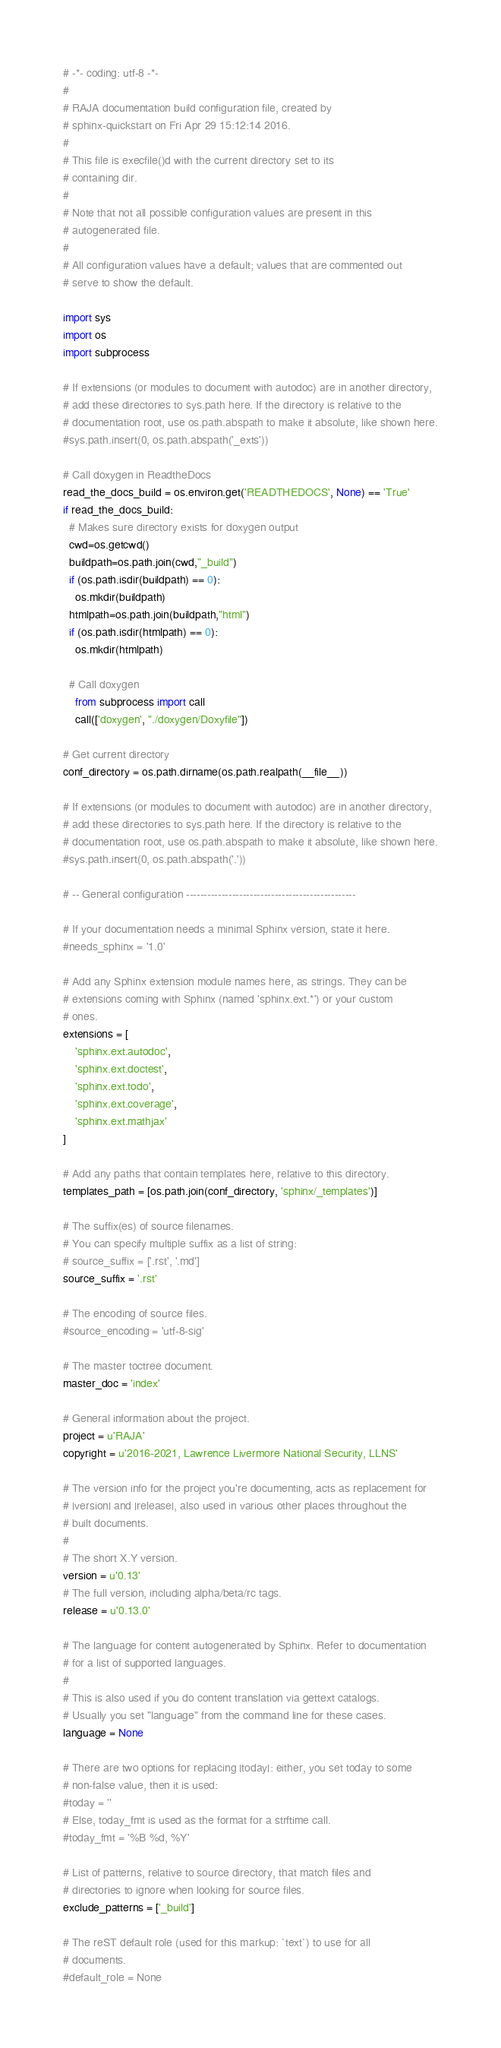<code> <loc_0><loc_0><loc_500><loc_500><_Python_># -*- coding: utf-8 -*-
#
# RAJA documentation build configuration file, created by
# sphinx-quickstart on Fri Apr 29 15:12:14 2016.
#
# This file is execfile()d with the current directory set to its
# containing dir.
#
# Note that not all possible configuration values are present in this
# autogenerated file.
#
# All configuration values have a default; values that are commented out
# serve to show the default.

import sys
import os
import subprocess

# If extensions (or modules to document with autodoc) are in another directory,
# add these directories to sys.path here. If the directory is relative to the
# documentation root, use os.path.abspath to make it absolute, like shown here.
#sys.path.insert(0, os.path.abspath('_exts'))

# Call doxygen in ReadtheDocs
read_the_docs_build = os.environ.get('READTHEDOCS', None) == 'True'
if read_the_docs_build:
  # Makes sure directory exists for doxygen output
  cwd=os.getcwd()
  buildpath=os.path.join(cwd,"_build")
  if (os.path.isdir(buildpath) == 0):
    os.mkdir(buildpath)
  htmlpath=os.path.join(buildpath,"html")
  if (os.path.isdir(htmlpath) == 0):
    os.mkdir(htmlpath)

  # Call doxygen
    from subprocess import call
    call(['doxygen', "./doxygen/Doxyfile"])

# Get current directory
conf_directory = os.path.dirname(os.path.realpath(__file__))

# If extensions (or modules to document with autodoc) are in another directory,
# add these directories to sys.path here. If the directory is relative to the
# documentation root, use os.path.abspath to make it absolute, like shown here.
#sys.path.insert(0, os.path.abspath('.'))

# -- General configuration ------------------------------------------------

# If your documentation needs a minimal Sphinx version, state it here.
#needs_sphinx = '1.0'

# Add any Sphinx extension module names here, as strings. They can be
# extensions coming with Sphinx (named 'sphinx.ext.*') or your custom
# ones.
extensions = [
    'sphinx.ext.autodoc',
    'sphinx.ext.doctest',
    'sphinx.ext.todo',
    'sphinx.ext.coverage',
    'sphinx.ext.mathjax'
]

# Add any paths that contain templates here, relative to this directory.
templates_path = [os.path.join(conf_directory, 'sphinx/_templates')]

# The suffix(es) of source filenames.
# You can specify multiple suffix as a list of string:
# source_suffix = ['.rst', '.md']
source_suffix = '.rst'

# The encoding of source files.
#source_encoding = 'utf-8-sig'

# The master toctree document.
master_doc = 'index'

# General information about the project.
project = u'RAJA'
copyright = u'2016-2021, Lawrence Livermore National Security, LLNS'

# The version info for the project you're documenting, acts as replacement for
# |version| and |release|, also used in various other places throughout the
# built documents.
#
# The short X.Y version.
version = u'0.13'
# The full version, including alpha/beta/rc tags.
release = u'0.13.0'

# The language for content autogenerated by Sphinx. Refer to documentation
# for a list of supported languages.
#
# This is also used if you do content translation via gettext catalogs.
# Usually you set "language" from the command line for these cases.
language = None

# There are two options for replacing |today|: either, you set today to some
# non-false value, then it is used:
#today = ''
# Else, today_fmt is used as the format for a strftime call.
#today_fmt = '%B %d, %Y'

# List of patterns, relative to source directory, that match files and
# directories to ignore when looking for source files.
exclude_patterns = ['_build']

# The reST default role (used for this markup: `text`) to use for all
# documents.
#default_role = None
</code> 